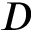Convert formula to latex. <formula><loc_0><loc_0><loc_500><loc_500>D</formula> 